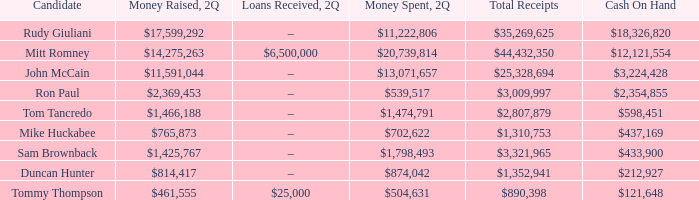Specify the financial outlay for 2q involving john mccain's candidacy. $13,071,657. 